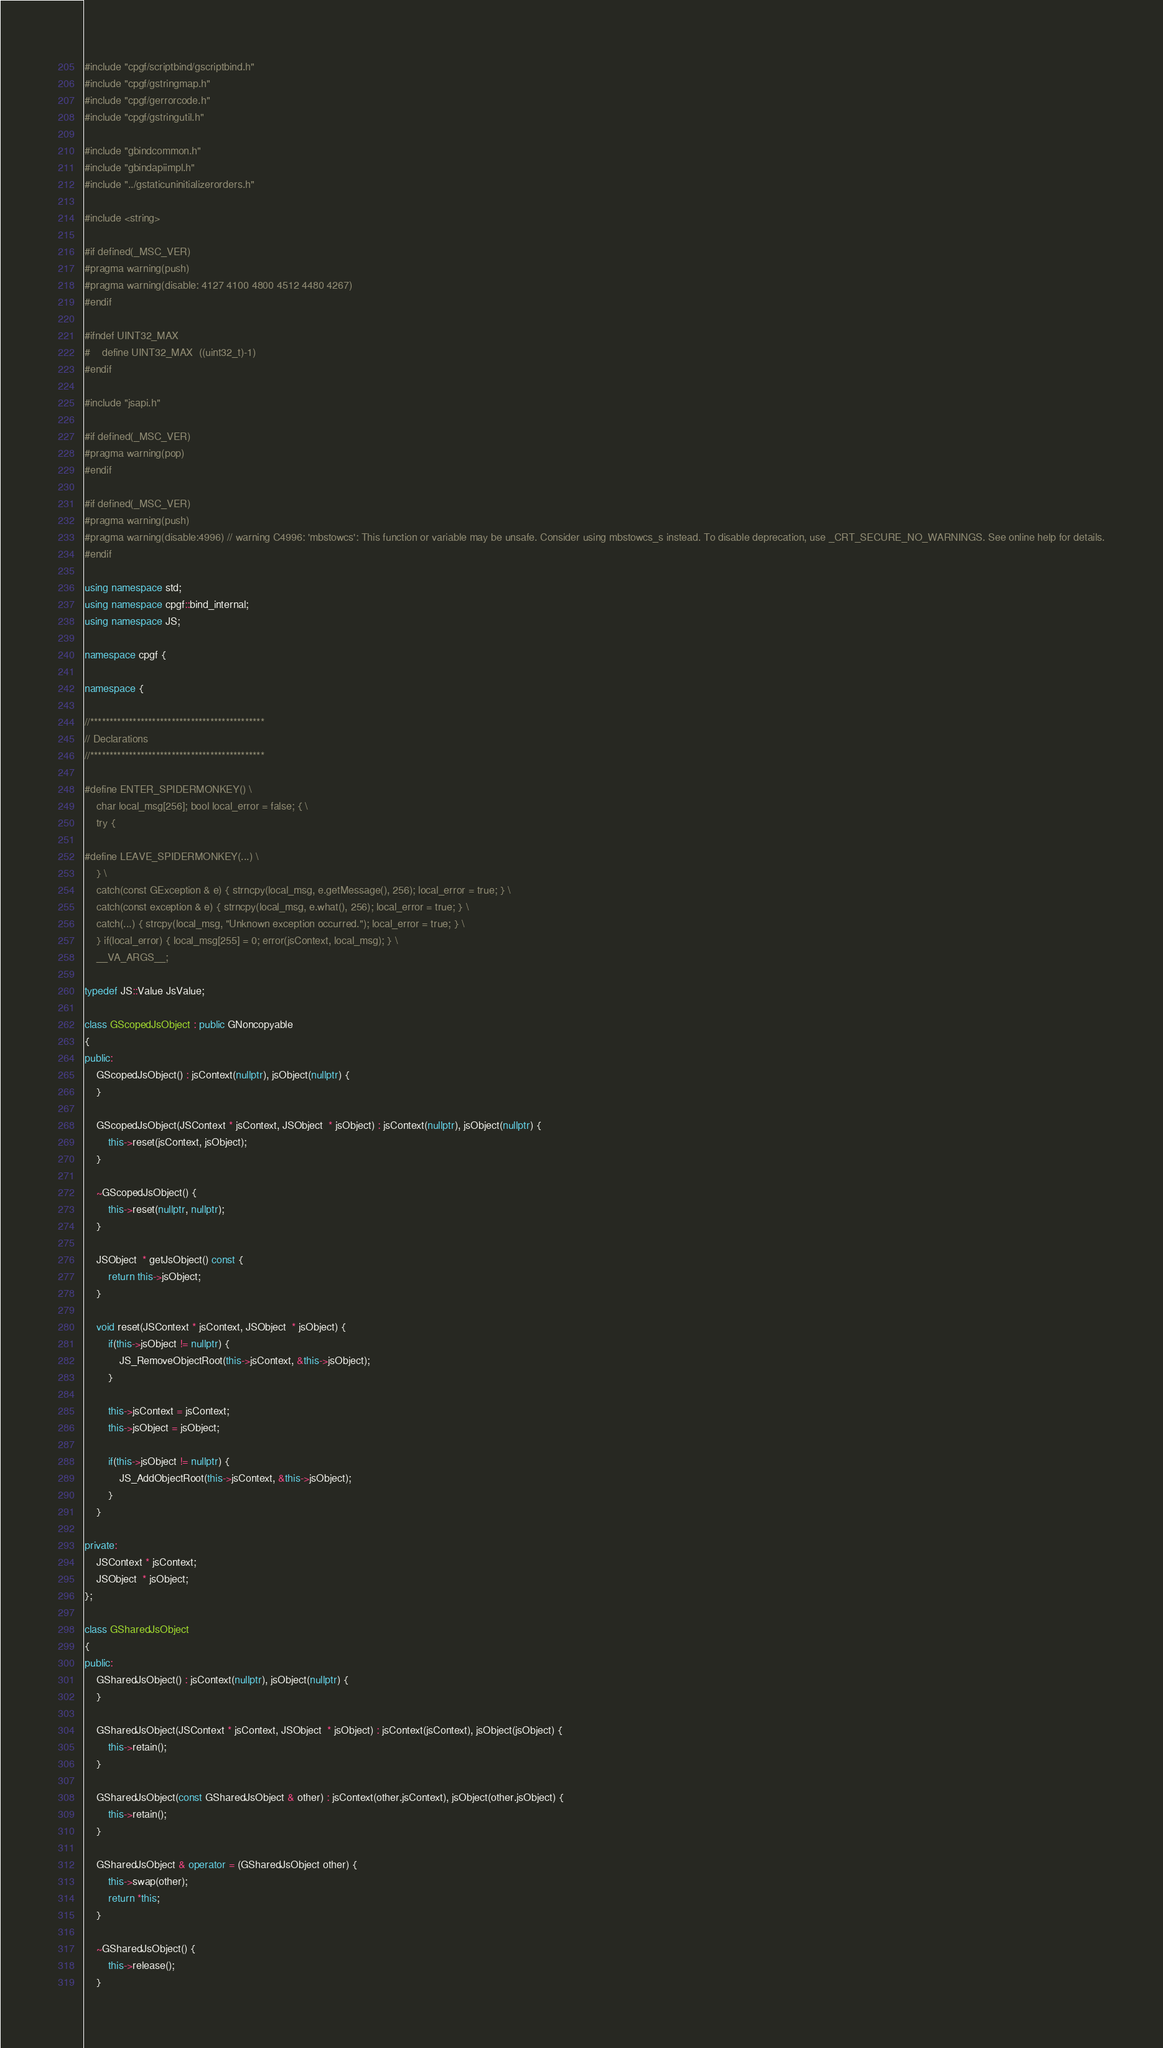Convert code to text. <code><loc_0><loc_0><loc_500><loc_500><_C++_>#include "cpgf/scriptbind/gscriptbind.h"
#include "cpgf/gstringmap.h"
#include "cpgf/gerrorcode.h"
#include "cpgf/gstringutil.h"

#include "gbindcommon.h"
#include "gbindapiimpl.h"
#include "../gstaticuninitializerorders.h"

#include <string>

#if defined(_MSC_VER)
#pragma warning(push)
#pragma warning(disable: 4127 4100 4800 4512 4480 4267)
#endif

#ifndef UINT32_MAX
#	define UINT32_MAX  ((uint32_t)-1)
#endif

#include "jsapi.h"

#if defined(_MSC_VER)
#pragma warning(pop)
#endif

#if defined(_MSC_VER)
#pragma warning(push)
#pragma warning(disable:4996) // warning C4996: 'mbstowcs': This function or variable may be unsafe. Consider using mbstowcs_s instead. To disable deprecation, use _CRT_SECURE_NO_WARNINGS. See online help for details.
#endif

using namespace std;
using namespace cpgf::bind_internal;
using namespace JS;

namespace cpgf {

namespace {

//*********************************************
// Declarations
//*********************************************

#define ENTER_SPIDERMONKEY() \
	char local_msg[256]; bool local_error = false; { \
	try {

#define LEAVE_SPIDERMONKEY(...) \
	} \
	catch(const GException & e) { strncpy(local_msg, e.getMessage(), 256); local_error = true; } \
	catch(const exception & e) { strncpy(local_msg, e.what(), 256); local_error = true; } \
	catch(...) { strcpy(local_msg, "Unknown exception occurred."); local_error = true; } \
	} if(local_error) { local_msg[255] = 0; error(jsContext, local_msg); } \
	__VA_ARGS__;

typedef JS::Value JsValue;

class GScopedJsObject : public GNoncopyable
{
public:
	GScopedJsObject() : jsContext(nullptr), jsObject(nullptr) {
	}

	GScopedJsObject(JSContext * jsContext, JSObject  * jsObject) : jsContext(nullptr), jsObject(nullptr) {
		this->reset(jsContext, jsObject);
	}

	~GScopedJsObject() {
		this->reset(nullptr, nullptr);
	}

	JSObject  * getJsObject() const {
		return this->jsObject;
	}

	void reset(JSContext * jsContext, JSObject  * jsObject) {
		if(this->jsObject != nullptr) {
			JS_RemoveObjectRoot(this->jsContext, &this->jsObject);
		}

		this->jsContext = jsContext;
		this->jsObject = jsObject;

		if(this->jsObject != nullptr) {
			JS_AddObjectRoot(this->jsContext, &this->jsObject);
		}
	}

private:
	JSContext * jsContext;
	JSObject  * jsObject;
};

class GSharedJsObject
{
public:
	GSharedJsObject() : jsContext(nullptr), jsObject(nullptr) {
	}

	GSharedJsObject(JSContext * jsContext, JSObject  * jsObject) : jsContext(jsContext), jsObject(jsObject) {
		this->retain();
	}

	GSharedJsObject(const GSharedJsObject & other) : jsContext(other.jsContext), jsObject(other.jsObject) {
		this->retain();
	}

	GSharedJsObject & operator = (GSharedJsObject other) {
		this->swap(other);
		return *this;
	}

	~GSharedJsObject() {
		this->release();
	}
</code> 